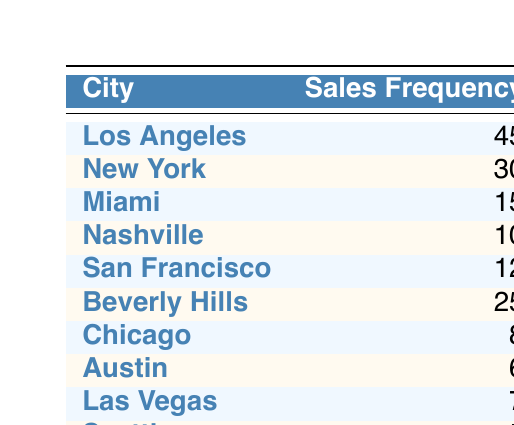What city has the highest sales frequency? The table shows the sales frequency for each city, and Los Angeles has the highest frequency with 45 sales.
Answer: Los Angeles How many cities have a sales frequency greater than 10? The cities with sales frequency greater than 10 are Los Angeles (45), New York (30), Beverly Hills (25), and Miami (15). This totals to 4 cities.
Answer: 4 Is there a city with a sales frequency of 5? Yes, the city of Seattle has a sales frequency of 5.
Answer: Yes What is the total sales frequency for cities in California (Los Angeles, San Francisco, Beverly Hills)? The sales frequencies for those cities are Los Angeles (45), San Francisco (12), and Beverly Hills (25). Their total is 45 + 12 + 25 = 82.
Answer: 82 Which city has the lowest sales frequency? The table indicates that Seattle has the lowest sales frequency with a value of 5.
Answer: Seattle What is the average sales frequency across all cities? To calculate the average, sum all sales frequencies: 45 + 30 + 15 + 10 + 12 + 25 + 8 + 6 + 7 + 5 = 63, and divide by the number of cities (10): 63 / 10 = 6.3.
Answer: 6.3 Are there more sales in New York than in Miami? Yes, New York has a sales frequency of 30, while Miami has a frequency of 15, which is less.
Answer: Yes How many sales were recorded in Chicago and Austin combined? The sales frequencies for Chicago (8) and Austin (6) sum up to 8 + 6 = 14.
Answer: 14 Which city has a higher sales frequency: Las Vegas or Nashville? Las Vegas has a frequency of 7 while Nashville has 10. Therefore, Nashville has a higher sales frequency.
Answer: Nashville 